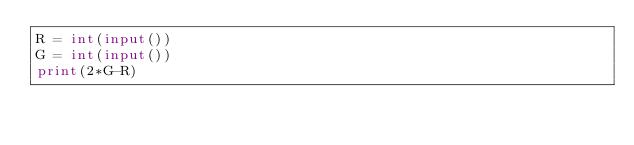Convert code to text. <code><loc_0><loc_0><loc_500><loc_500><_Python_>R = int(input())
G = int(input())
print(2*G-R)</code> 